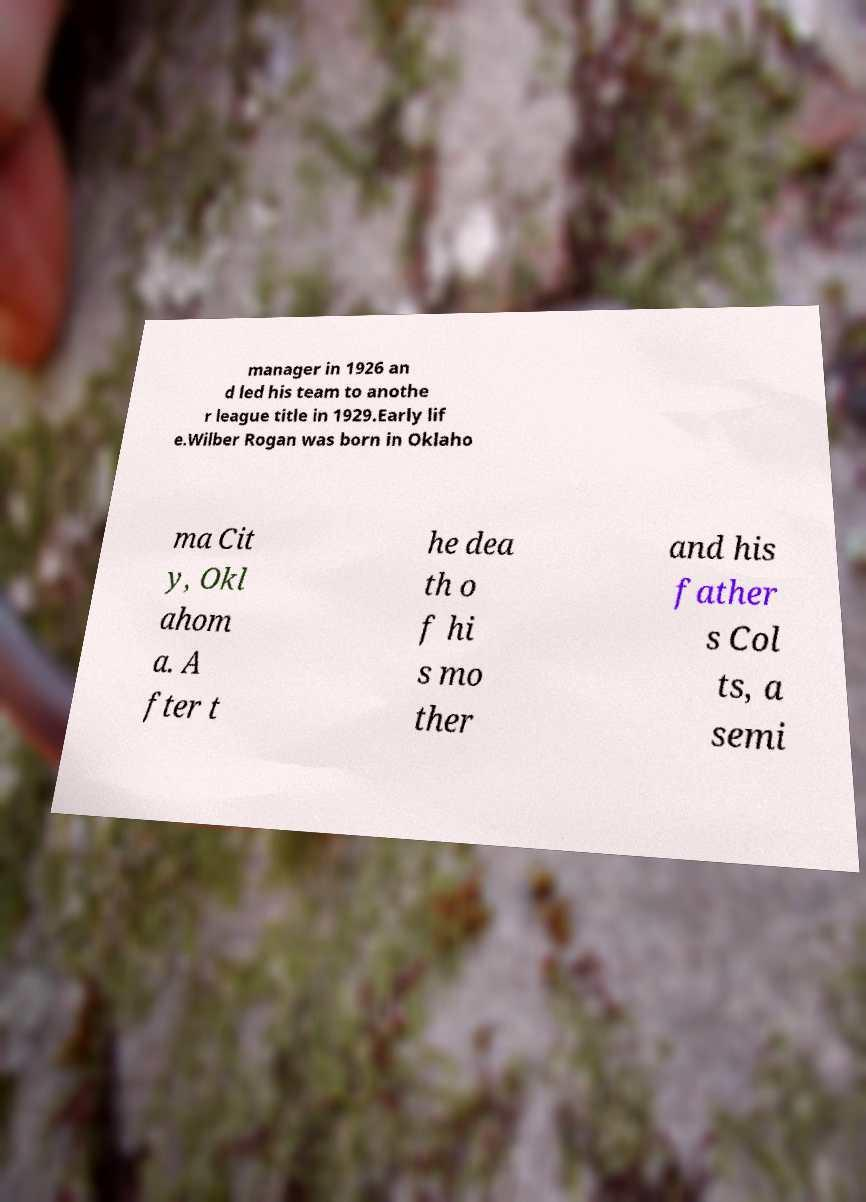Could you assist in decoding the text presented in this image and type it out clearly? manager in 1926 an d led his team to anothe r league title in 1929.Early lif e.Wilber Rogan was born in Oklaho ma Cit y, Okl ahom a. A fter t he dea th o f hi s mo ther and his father s Col ts, a semi 